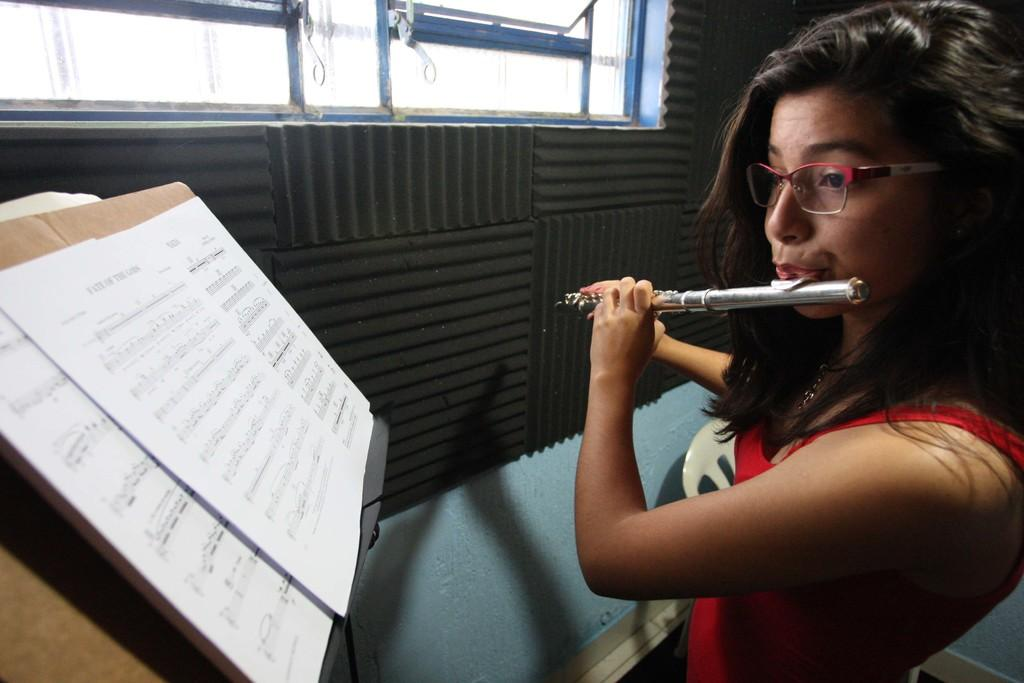What is the person in the image doing? The person in the image is playing the flute. What is in front of the person? There are papers in front of the person. What can be seen to the right of the person? There is a window to the right of the person. What is associated with the window? There is a wall associated with the window. What type of vegetable is being processed by the machine in the image? There is no machine or vegetable present in the image. 